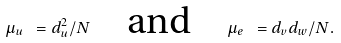Convert formula to latex. <formula><loc_0><loc_0><loc_500><loc_500>\mu _ { u } \ = d _ { u } ^ { 2 } / N \quad \text {and} \quad \mu _ { e } \ = d _ { v } d _ { w } / N .</formula> 